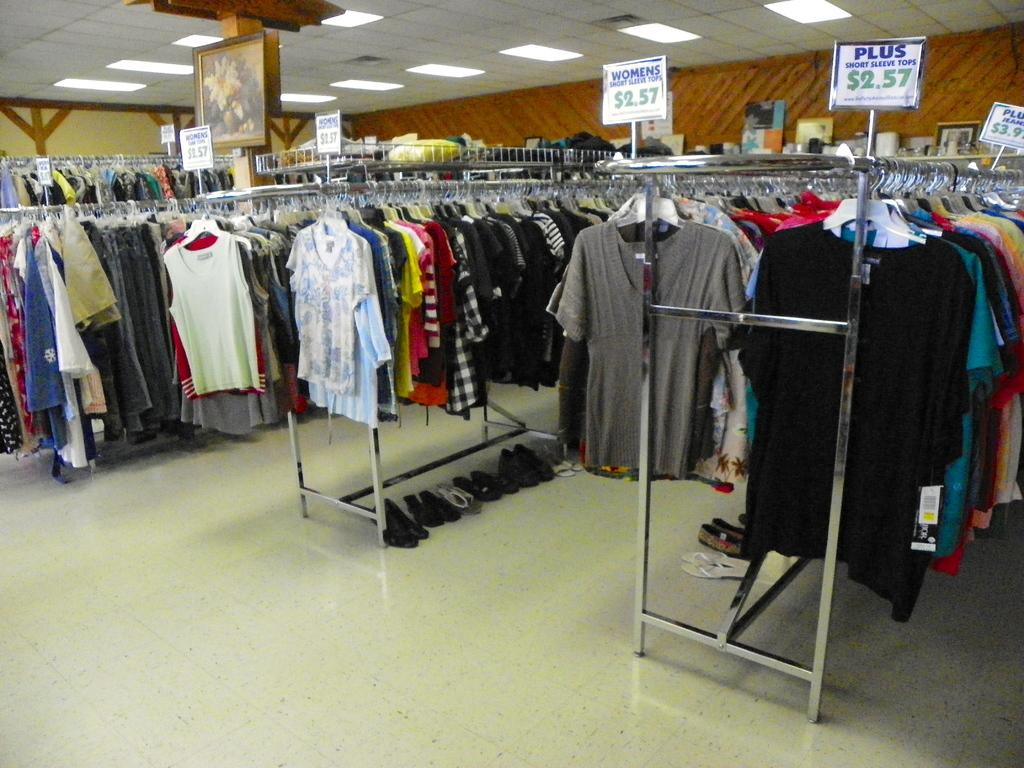<image>
Write a terse but informative summary of the picture. Several racks of shirts are displayed in a store with a sign on the right with the word plus on it in blue. 